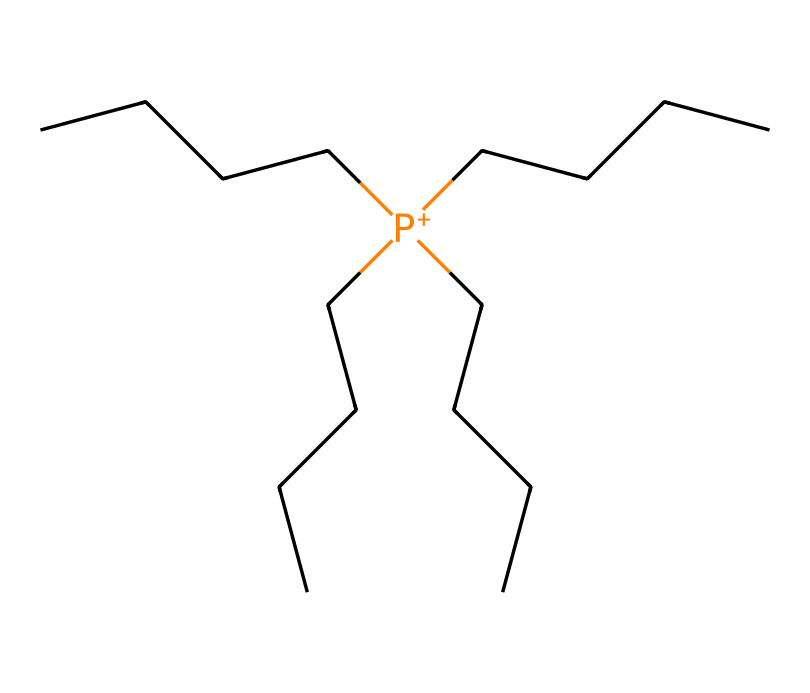What is the central atom in this compound? The structure demonstrates a phosphorus atom as indicated by the symbol “P” at the core of the compound's formula, which is characteristic of phosphonium compounds.
Answer: phosphorus How many carbon atoms are present in this compound? Analyzing the structure, there are four carbon (C) chains connected to the central phosphorus, and each chain appears to consist of 4 carbon atoms, totaling 16 carbon atoms in the entire structure.
Answer: 16 What type of bond is predominant in phosphonium compounds? The structure predominantly exhibits covalent bonding, as indicated by the connectivity between carbon and phosphorus atoms without any ionic character shown in the SMILES notation.
Answer: covalent What functional group is characteristic of phosphonium compounds? The presence of the phosphorus atom bonded to four alkyl groups signifies the quaternary ammonium-like functional group characteristic of phosphonium compounds.
Answer: quaternary ammonium How does the alkyl chain length affect the antimicrobial properties of this compound? Longer alkyl chains in phosphonium compounds often enhance hydrophobicity, thus improving interaction with microbial membranes, leading to better antimicrobial efficacy.
Answer: hydrophobicity What is the overall charge of this phosphonium compound? The notation shows phosphorus is positively charged (indicated by "P+"), confirming that this compound has a net positive charge typical of phosphonium species.
Answer: positive What is a common application of phosphonium compounds in preservation? The unique antimicrobial properties of phosphonium compounds allow for effective prevention of microbial growth on preserved materials, making them valuable for the preservation of books and documents.
Answer: preservation 